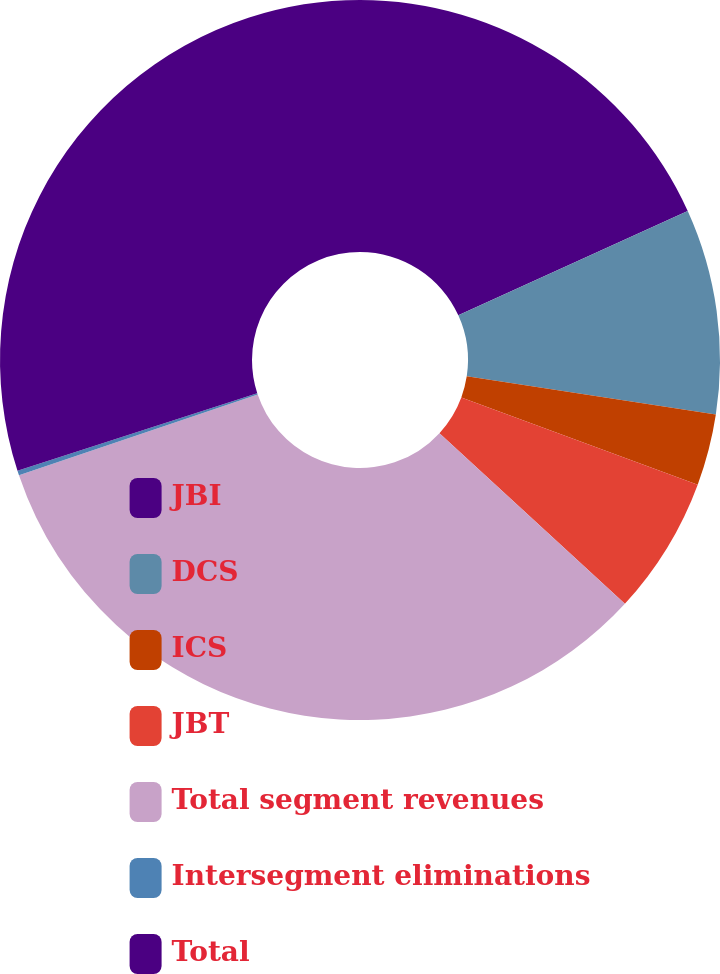<chart> <loc_0><loc_0><loc_500><loc_500><pie_chart><fcel>JBI<fcel>DCS<fcel>ICS<fcel>JBT<fcel>Total segment revenues<fcel>Intersegment eliminations<fcel>Total<nl><fcel>18.21%<fcel>9.21%<fcel>3.21%<fcel>6.21%<fcel>32.97%<fcel>0.21%<fcel>29.98%<nl></chart> 